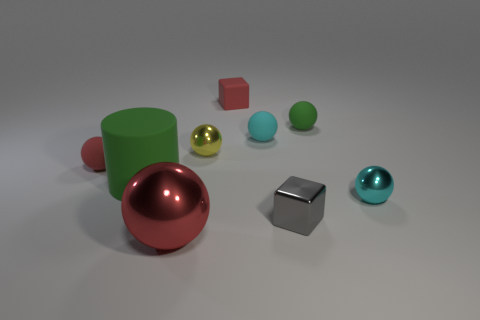Subtract all red balls. How many balls are left? 4 Subtract all small red spheres. How many spheres are left? 5 Subtract all blue balls. Subtract all green cylinders. How many balls are left? 6 Add 1 tiny gray things. How many objects exist? 10 Subtract all cylinders. How many objects are left? 8 Add 6 gray things. How many gray things exist? 7 Subtract 1 red blocks. How many objects are left? 8 Subtract all tiny gray metal blocks. Subtract all yellow metal objects. How many objects are left? 7 Add 3 red rubber things. How many red rubber things are left? 5 